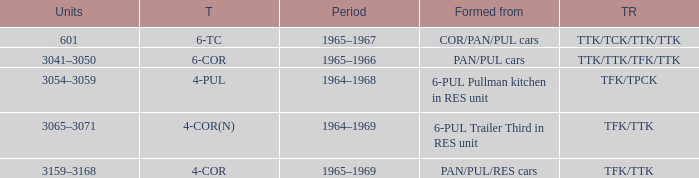Name the typed for formed from 6-pul trailer third in res unit 4-COR(N). 